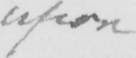Can you tell me what this handwritten text says? upon 